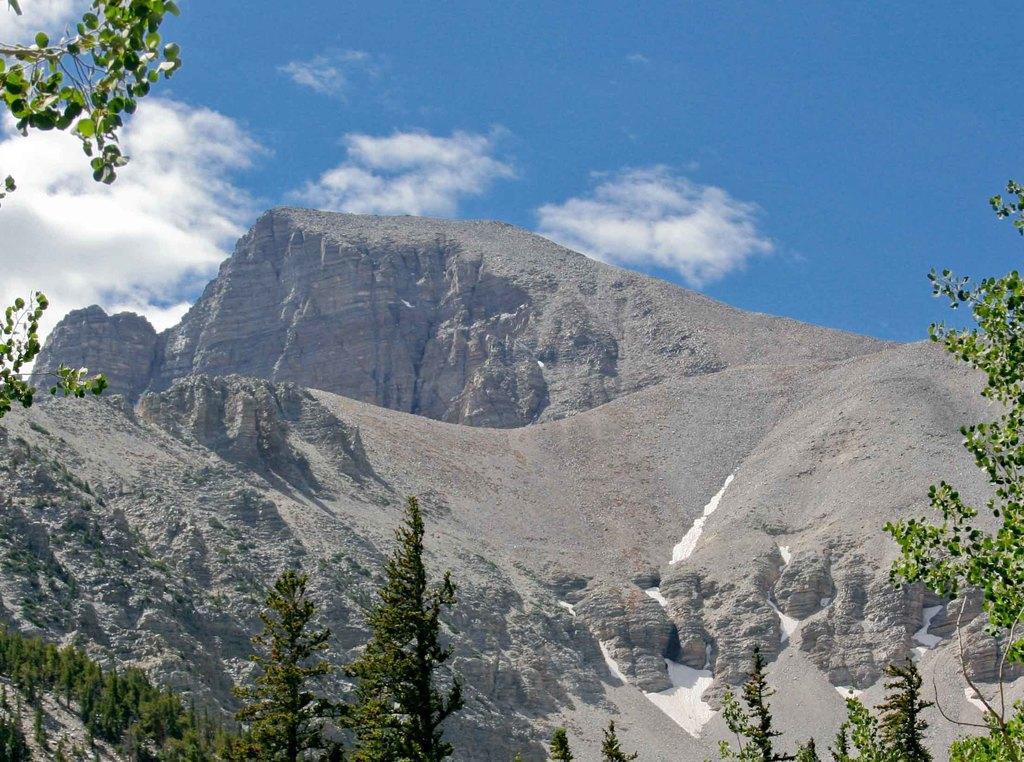Please provide a concise description of this image. This image is taken outdoors. At the top of the image there is the sky with clouds. At the bottom of the image there are a few trees on the ground. In the middle of the image there are a few hills and rocks. 